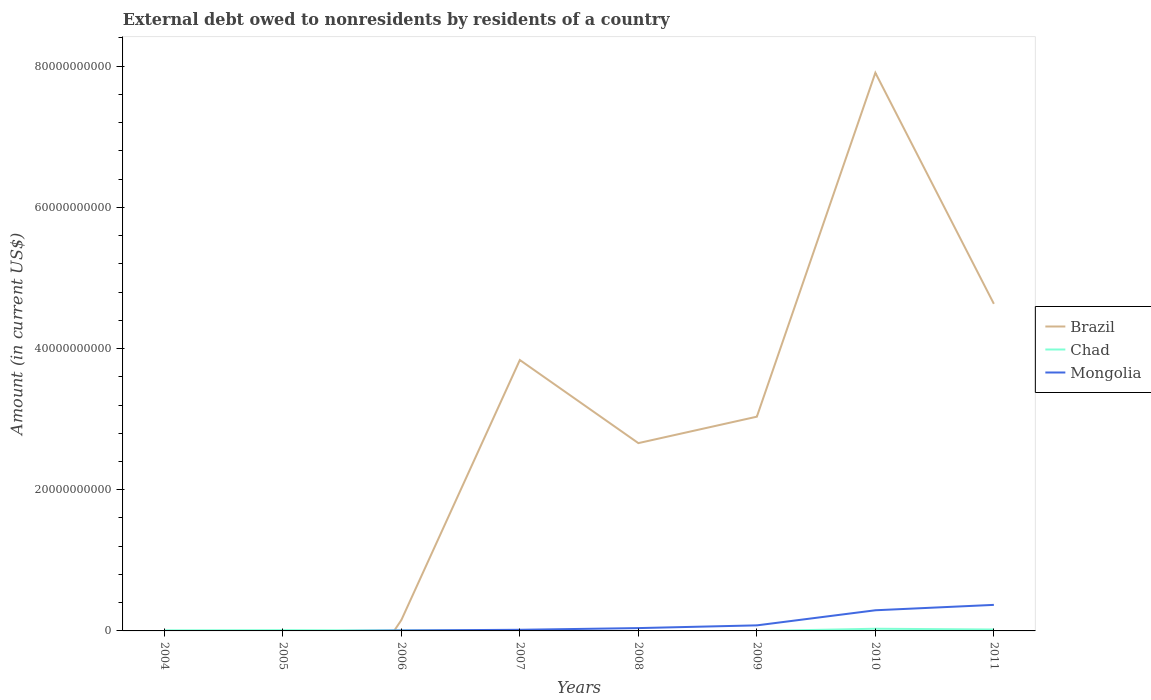How many different coloured lines are there?
Give a very brief answer. 3. Across all years, what is the maximum external debt owed by residents in Brazil?
Ensure brevity in your answer.  0. What is the total external debt owed by residents in Chad in the graph?
Offer a very short reply. -9.06e+07. What is the difference between the highest and the second highest external debt owed by residents in Mongolia?
Ensure brevity in your answer.  3.69e+09. What is the difference between the highest and the lowest external debt owed by residents in Chad?
Offer a terse response. 3. How many lines are there?
Provide a short and direct response. 3. Are the values on the major ticks of Y-axis written in scientific E-notation?
Ensure brevity in your answer.  No. Does the graph contain grids?
Keep it short and to the point. No. Where does the legend appear in the graph?
Ensure brevity in your answer.  Center right. How many legend labels are there?
Give a very brief answer. 3. What is the title of the graph?
Offer a very short reply. External debt owed to nonresidents by residents of a country. What is the Amount (in current US$) of Chad in 2004?
Keep it short and to the point. 8.47e+07. What is the Amount (in current US$) in Mongolia in 2004?
Offer a terse response. 0. What is the Amount (in current US$) in Brazil in 2005?
Your answer should be very brief. 0. What is the Amount (in current US$) of Chad in 2005?
Make the answer very short. 1.09e+08. What is the Amount (in current US$) in Brazil in 2006?
Keep it short and to the point. 1.54e+09. What is the Amount (in current US$) of Chad in 2006?
Offer a terse response. 6.11e+07. What is the Amount (in current US$) in Mongolia in 2006?
Give a very brief answer. 6.25e+07. What is the Amount (in current US$) in Brazil in 2007?
Keep it short and to the point. 3.84e+1. What is the Amount (in current US$) of Chad in 2007?
Provide a short and direct response. 2.07e+07. What is the Amount (in current US$) of Mongolia in 2007?
Give a very brief answer. 1.62e+08. What is the Amount (in current US$) in Brazil in 2008?
Offer a terse response. 2.66e+1. What is the Amount (in current US$) in Mongolia in 2008?
Keep it short and to the point. 4.01e+08. What is the Amount (in current US$) of Brazil in 2009?
Offer a very short reply. 3.03e+1. What is the Amount (in current US$) in Chad in 2009?
Ensure brevity in your answer.  0. What is the Amount (in current US$) in Mongolia in 2009?
Your answer should be very brief. 7.87e+08. What is the Amount (in current US$) in Brazil in 2010?
Provide a short and direct response. 7.91e+1. What is the Amount (in current US$) of Chad in 2010?
Offer a very short reply. 3.11e+08. What is the Amount (in current US$) of Mongolia in 2010?
Provide a short and direct response. 2.93e+09. What is the Amount (in current US$) of Brazil in 2011?
Ensure brevity in your answer.  4.63e+1. What is the Amount (in current US$) of Chad in 2011?
Keep it short and to the point. 2.00e+08. What is the Amount (in current US$) in Mongolia in 2011?
Give a very brief answer. 3.69e+09. Across all years, what is the maximum Amount (in current US$) in Brazil?
Make the answer very short. 7.91e+1. Across all years, what is the maximum Amount (in current US$) in Chad?
Offer a terse response. 3.11e+08. Across all years, what is the maximum Amount (in current US$) of Mongolia?
Provide a succinct answer. 3.69e+09. Across all years, what is the minimum Amount (in current US$) of Brazil?
Provide a succinct answer. 0. Across all years, what is the minimum Amount (in current US$) in Chad?
Offer a terse response. 0. What is the total Amount (in current US$) in Brazil in the graph?
Your answer should be compact. 2.22e+11. What is the total Amount (in current US$) of Chad in the graph?
Give a very brief answer. 7.86e+08. What is the total Amount (in current US$) of Mongolia in the graph?
Provide a succinct answer. 8.03e+09. What is the difference between the Amount (in current US$) of Chad in 2004 and that in 2005?
Keep it short and to the point. -2.45e+07. What is the difference between the Amount (in current US$) of Chad in 2004 and that in 2006?
Offer a terse response. 2.37e+07. What is the difference between the Amount (in current US$) in Chad in 2004 and that in 2007?
Offer a very short reply. 6.41e+07. What is the difference between the Amount (in current US$) in Chad in 2004 and that in 2010?
Your answer should be compact. -2.26e+08. What is the difference between the Amount (in current US$) in Chad in 2004 and that in 2011?
Offer a very short reply. -1.15e+08. What is the difference between the Amount (in current US$) of Chad in 2005 and that in 2006?
Your response must be concise. 4.81e+07. What is the difference between the Amount (in current US$) of Chad in 2005 and that in 2007?
Ensure brevity in your answer.  8.85e+07. What is the difference between the Amount (in current US$) in Chad in 2005 and that in 2010?
Keep it short and to the point. -2.01e+08. What is the difference between the Amount (in current US$) of Chad in 2005 and that in 2011?
Provide a short and direct response. -9.06e+07. What is the difference between the Amount (in current US$) of Brazil in 2006 and that in 2007?
Provide a succinct answer. -3.68e+1. What is the difference between the Amount (in current US$) in Chad in 2006 and that in 2007?
Offer a terse response. 4.04e+07. What is the difference between the Amount (in current US$) of Mongolia in 2006 and that in 2007?
Your answer should be very brief. -9.96e+07. What is the difference between the Amount (in current US$) of Brazil in 2006 and that in 2008?
Offer a very short reply. -2.51e+1. What is the difference between the Amount (in current US$) of Mongolia in 2006 and that in 2008?
Offer a terse response. -3.38e+08. What is the difference between the Amount (in current US$) in Brazil in 2006 and that in 2009?
Your answer should be very brief. -2.88e+1. What is the difference between the Amount (in current US$) of Mongolia in 2006 and that in 2009?
Your answer should be compact. -7.25e+08. What is the difference between the Amount (in current US$) of Brazil in 2006 and that in 2010?
Keep it short and to the point. -7.75e+1. What is the difference between the Amount (in current US$) in Chad in 2006 and that in 2010?
Make the answer very short. -2.49e+08. What is the difference between the Amount (in current US$) of Mongolia in 2006 and that in 2010?
Offer a very short reply. -2.86e+09. What is the difference between the Amount (in current US$) in Brazil in 2006 and that in 2011?
Provide a short and direct response. -4.48e+1. What is the difference between the Amount (in current US$) in Chad in 2006 and that in 2011?
Your answer should be compact. -1.39e+08. What is the difference between the Amount (in current US$) of Mongolia in 2006 and that in 2011?
Your answer should be very brief. -3.63e+09. What is the difference between the Amount (in current US$) in Brazil in 2007 and that in 2008?
Your response must be concise. 1.18e+1. What is the difference between the Amount (in current US$) in Mongolia in 2007 and that in 2008?
Offer a terse response. -2.39e+08. What is the difference between the Amount (in current US$) in Brazil in 2007 and that in 2009?
Offer a very short reply. 8.03e+09. What is the difference between the Amount (in current US$) in Mongolia in 2007 and that in 2009?
Give a very brief answer. -6.25e+08. What is the difference between the Amount (in current US$) of Brazil in 2007 and that in 2010?
Offer a terse response. -4.07e+1. What is the difference between the Amount (in current US$) in Chad in 2007 and that in 2010?
Keep it short and to the point. -2.90e+08. What is the difference between the Amount (in current US$) in Mongolia in 2007 and that in 2010?
Ensure brevity in your answer.  -2.76e+09. What is the difference between the Amount (in current US$) of Brazil in 2007 and that in 2011?
Provide a succinct answer. -7.96e+09. What is the difference between the Amount (in current US$) in Chad in 2007 and that in 2011?
Offer a very short reply. -1.79e+08. What is the difference between the Amount (in current US$) of Mongolia in 2007 and that in 2011?
Offer a very short reply. -3.53e+09. What is the difference between the Amount (in current US$) of Brazil in 2008 and that in 2009?
Your answer should be very brief. -3.74e+09. What is the difference between the Amount (in current US$) of Mongolia in 2008 and that in 2009?
Ensure brevity in your answer.  -3.87e+08. What is the difference between the Amount (in current US$) of Brazil in 2008 and that in 2010?
Provide a succinct answer. -5.25e+1. What is the difference between the Amount (in current US$) of Mongolia in 2008 and that in 2010?
Provide a short and direct response. -2.52e+09. What is the difference between the Amount (in current US$) in Brazil in 2008 and that in 2011?
Provide a succinct answer. -1.97e+1. What is the difference between the Amount (in current US$) in Mongolia in 2008 and that in 2011?
Make the answer very short. -3.29e+09. What is the difference between the Amount (in current US$) of Brazil in 2009 and that in 2010?
Keep it short and to the point. -4.87e+1. What is the difference between the Amount (in current US$) in Mongolia in 2009 and that in 2010?
Provide a succinct answer. -2.14e+09. What is the difference between the Amount (in current US$) in Brazil in 2009 and that in 2011?
Your answer should be compact. -1.60e+1. What is the difference between the Amount (in current US$) of Mongolia in 2009 and that in 2011?
Your answer should be compact. -2.90e+09. What is the difference between the Amount (in current US$) in Brazil in 2010 and that in 2011?
Your response must be concise. 3.27e+1. What is the difference between the Amount (in current US$) of Chad in 2010 and that in 2011?
Keep it short and to the point. 1.11e+08. What is the difference between the Amount (in current US$) of Mongolia in 2010 and that in 2011?
Provide a short and direct response. -7.64e+08. What is the difference between the Amount (in current US$) of Chad in 2004 and the Amount (in current US$) of Mongolia in 2006?
Offer a very short reply. 2.22e+07. What is the difference between the Amount (in current US$) of Chad in 2004 and the Amount (in current US$) of Mongolia in 2007?
Ensure brevity in your answer.  -7.74e+07. What is the difference between the Amount (in current US$) in Chad in 2004 and the Amount (in current US$) in Mongolia in 2008?
Offer a very short reply. -3.16e+08. What is the difference between the Amount (in current US$) of Chad in 2004 and the Amount (in current US$) of Mongolia in 2009?
Keep it short and to the point. -7.03e+08. What is the difference between the Amount (in current US$) of Chad in 2004 and the Amount (in current US$) of Mongolia in 2010?
Ensure brevity in your answer.  -2.84e+09. What is the difference between the Amount (in current US$) in Chad in 2004 and the Amount (in current US$) in Mongolia in 2011?
Your answer should be compact. -3.60e+09. What is the difference between the Amount (in current US$) of Chad in 2005 and the Amount (in current US$) of Mongolia in 2006?
Your response must be concise. 4.67e+07. What is the difference between the Amount (in current US$) in Chad in 2005 and the Amount (in current US$) in Mongolia in 2007?
Ensure brevity in your answer.  -5.29e+07. What is the difference between the Amount (in current US$) of Chad in 2005 and the Amount (in current US$) of Mongolia in 2008?
Offer a terse response. -2.92e+08. What is the difference between the Amount (in current US$) in Chad in 2005 and the Amount (in current US$) in Mongolia in 2009?
Make the answer very short. -6.78e+08. What is the difference between the Amount (in current US$) of Chad in 2005 and the Amount (in current US$) of Mongolia in 2010?
Give a very brief answer. -2.82e+09. What is the difference between the Amount (in current US$) in Chad in 2005 and the Amount (in current US$) in Mongolia in 2011?
Keep it short and to the point. -3.58e+09. What is the difference between the Amount (in current US$) in Brazil in 2006 and the Amount (in current US$) in Chad in 2007?
Provide a succinct answer. 1.52e+09. What is the difference between the Amount (in current US$) in Brazil in 2006 and the Amount (in current US$) in Mongolia in 2007?
Your answer should be compact. 1.38e+09. What is the difference between the Amount (in current US$) in Chad in 2006 and the Amount (in current US$) in Mongolia in 2007?
Offer a very short reply. -1.01e+08. What is the difference between the Amount (in current US$) in Brazil in 2006 and the Amount (in current US$) in Mongolia in 2008?
Keep it short and to the point. 1.14e+09. What is the difference between the Amount (in current US$) of Chad in 2006 and the Amount (in current US$) of Mongolia in 2008?
Keep it short and to the point. -3.40e+08. What is the difference between the Amount (in current US$) in Brazil in 2006 and the Amount (in current US$) in Mongolia in 2009?
Your answer should be very brief. 7.50e+08. What is the difference between the Amount (in current US$) in Chad in 2006 and the Amount (in current US$) in Mongolia in 2009?
Make the answer very short. -7.26e+08. What is the difference between the Amount (in current US$) of Brazil in 2006 and the Amount (in current US$) of Chad in 2010?
Your answer should be very brief. 1.23e+09. What is the difference between the Amount (in current US$) in Brazil in 2006 and the Amount (in current US$) in Mongolia in 2010?
Give a very brief answer. -1.39e+09. What is the difference between the Amount (in current US$) in Chad in 2006 and the Amount (in current US$) in Mongolia in 2010?
Provide a succinct answer. -2.86e+09. What is the difference between the Amount (in current US$) in Brazil in 2006 and the Amount (in current US$) in Chad in 2011?
Offer a terse response. 1.34e+09. What is the difference between the Amount (in current US$) in Brazil in 2006 and the Amount (in current US$) in Mongolia in 2011?
Offer a very short reply. -2.15e+09. What is the difference between the Amount (in current US$) of Chad in 2006 and the Amount (in current US$) of Mongolia in 2011?
Provide a succinct answer. -3.63e+09. What is the difference between the Amount (in current US$) in Brazil in 2007 and the Amount (in current US$) in Mongolia in 2008?
Make the answer very short. 3.80e+1. What is the difference between the Amount (in current US$) in Chad in 2007 and the Amount (in current US$) in Mongolia in 2008?
Give a very brief answer. -3.80e+08. What is the difference between the Amount (in current US$) of Brazil in 2007 and the Amount (in current US$) of Mongolia in 2009?
Ensure brevity in your answer.  3.76e+1. What is the difference between the Amount (in current US$) in Chad in 2007 and the Amount (in current US$) in Mongolia in 2009?
Make the answer very short. -7.67e+08. What is the difference between the Amount (in current US$) in Brazil in 2007 and the Amount (in current US$) in Chad in 2010?
Provide a short and direct response. 3.81e+1. What is the difference between the Amount (in current US$) of Brazil in 2007 and the Amount (in current US$) of Mongolia in 2010?
Provide a short and direct response. 3.54e+1. What is the difference between the Amount (in current US$) in Chad in 2007 and the Amount (in current US$) in Mongolia in 2010?
Give a very brief answer. -2.90e+09. What is the difference between the Amount (in current US$) of Brazil in 2007 and the Amount (in current US$) of Chad in 2011?
Keep it short and to the point. 3.82e+1. What is the difference between the Amount (in current US$) in Brazil in 2007 and the Amount (in current US$) in Mongolia in 2011?
Give a very brief answer. 3.47e+1. What is the difference between the Amount (in current US$) of Chad in 2007 and the Amount (in current US$) of Mongolia in 2011?
Provide a short and direct response. -3.67e+09. What is the difference between the Amount (in current US$) of Brazil in 2008 and the Amount (in current US$) of Mongolia in 2009?
Provide a succinct answer. 2.58e+1. What is the difference between the Amount (in current US$) of Brazil in 2008 and the Amount (in current US$) of Chad in 2010?
Offer a terse response. 2.63e+1. What is the difference between the Amount (in current US$) of Brazil in 2008 and the Amount (in current US$) of Mongolia in 2010?
Offer a very short reply. 2.37e+1. What is the difference between the Amount (in current US$) of Brazil in 2008 and the Amount (in current US$) of Chad in 2011?
Ensure brevity in your answer.  2.64e+1. What is the difference between the Amount (in current US$) in Brazil in 2008 and the Amount (in current US$) in Mongolia in 2011?
Provide a short and direct response. 2.29e+1. What is the difference between the Amount (in current US$) in Brazil in 2009 and the Amount (in current US$) in Chad in 2010?
Provide a succinct answer. 3.00e+1. What is the difference between the Amount (in current US$) in Brazil in 2009 and the Amount (in current US$) in Mongolia in 2010?
Offer a terse response. 2.74e+1. What is the difference between the Amount (in current US$) of Brazil in 2009 and the Amount (in current US$) of Chad in 2011?
Provide a short and direct response. 3.01e+1. What is the difference between the Amount (in current US$) in Brazil in 2009 and the Amount (in current US$) in Mongolia in 2011?
Provide a succinct answer. 2.67e+1. What is the difference between the Amount (in current US$) in Brazil in 2010 and the Amount (in current US$) in Chad in 2011?
Ensure brevity in your answer.  7.89e+1. What is the difference between the Amount (in current US$) in Brazil in 2010 and the Amount (in current US$) in Mongolia in 2011?
Make the answer very short. 7.54e+1. What is the difference between the Amount (in current US$) in Chad in 2010 and the Amount (in current US$) in Mongolia in 2011?
Your answer should be compact. -3.38e+09. What is the average Amount (in current US$) of Brazil per year?
Provide a succinct answer. 2.78e+1. What is the average Amount (in current US$) in Chad per year?
Make the answer very short. 9.83e+07. What is the average Amount (in current US$) in Mongolia per year?
Keep it short and to the point. 1.00e+09. In the year 2006, what is the difference between the Amount (in current US$) of Brazil and Amount (in current US$) of Chad?
Offer a terse response. 1.48e+09. In the year 2006, what is the difference between the Amount (in current US$) in Brazil and Amount (in current US$) in Mongolia?
Give a very brief answer. 1.47e+09. In the year 2006, what is the difference between the Amount (in current US$) in Chad and Amount (in current US$) in Mongolia?
Your answer should be compact. -1.45e+06. In the year 2007, what is the difference between the Amount (in current US$) in Brazil and Amount (in current US$) in Chad?
Make the answer very short. 3.84e+1. In the year 2007, what is the difference between the Amount (in current US$) in Brazil and Amount (in current US$) in Mongolia?
Offer a terse response. 3.82e+1. In the year 2007, what is the difference between the Amount (in current US$) in Chad and Amount (in current US$) in Mongolia?
Ensure brevity in your answer.  -1.41e+08. In the year 2008, what is the difference between the Amount (in current US$) in Brazil and Amount (in current US$) in Mongolia?
Your answer should be very brief. 2.62e+1. In the year 2009, what is the difference between the Amount (in current US$) in Brazil and Amount (in current US$) in Mongolia?
Make the answer very short. 2.96e+1. In the year 2010, what is the difference between the Amount (in current US$) of Brazil and Amount (in current US$) of Chad?
Give a very brief answer. 7.87e+1. In the year 2010, what is the difference between the Amount (in current US$) of Brazil and Amount (in current US$) of Mongolia?
Your answer should be compact. 7.61e+1. In the year 2010, what is the difference between the Amount (in current US$) of Chad and Amount (in current US$) of Mongolia?
Provide a short and direct response. -2.61e+09. In the year 2011, what is the difference between the Amount (in current US$) in Brazil and Amount (in current US$) in Chad?
Your response must be concise. 4.61e+1. In the year 2011, what is the difference between the Amount (in current US$) of Brazil and Amount (in current US$) of Mongolia?
Your response must be concise. 4.26e+1. In the year 2011, what is the difference between the Amount (in current US$) of Chad and Amount (in current US$) of Mongolia?
Your answer should be very brief. -3.49e+09. What is the ratio of the Amount (in current US$) in Chad in 2004 to that in 2005?
Your answer should be compact. 0.78. What is the ratio of the Amount (in current US$) in Chad in 2004 to that in 2006?
Offer a very short reply. 1.39. What is the ratio of the Amount (in current US$) of Chad in 2004 to that in 2007?
Your answer should be compact. 4.1. What is the ratio of the Amount (in current US$) of Chad in 2004 to that in 2010?
Your response must be concise. 0.27. What is the ratio of the Amount (in current US$) of Chad in 2004 to that in 2011?
Give a very brief answer. 0.42. What is the ratio of the Amount (in current US$) of Chad in 2005 to that in 2006?
Your answer should be very brief. 1.79. What is the ratio of the Amount (in current US$) of Chad in 2005 to that in 2007?
Provide a short and direct response. 5.28. What is the ratio of the Amount (in current US$) in Chad in 2005 to that in 2010?
Your response must be concise. 0.35. What is the ratio of the Amount (in current US$) in Chad in 2005 to that in 2011?
Your response must be concise. 0.55. What is the ratio of the Amount (in current US$) in Brazil in 2006 to that in 2007?
Provide a short and direct response. 0.04. What is the ratio of the Amount (in current US$) of Chad in 2006 to that in 2007?
Your answer should be compact. 2.95. What is the ratio of the Amount (in current US$) in Mongolia in 2006 to that in 2007?
Your answer should be compact. 0.39. What is the ratio of the Amount (in current US$) in Brazil in 2006 to that in 2008?
Offer a terse response. 0.06. What is the ratio of the Amount (in current US$) of Mongolia in 2006 to that in 2008?
Make the answer very short. 0.16. What is the ratio of the Amount (in current US$) of Brazil in 2006 to that in 2009?
Provide a succinct answer. 0.05. What is the ratio of the Amount (in current US$) in Mongolia in 2006 to that in 2009?
Your response must be concise. 0.08. What is the ratio of the Amount (in current US$) of Brazil in 2006 to that in 2010?
Keep it short and to the point. 0.02. What is the ratio of the Amount (in current US$) in Chad in 2006 to that in 2010?
Provide a succinct answer. 0.2. What is the ratio of the Amount (in current US$) in Mongolia in 2006 to that in 2010?
Your response must be concise. 0.02. What is the ratio of the Amount (in current US$) of Brazil in 2006 to that in 2011?
Your answer should be compact. 0.03. What is the ratio of the Amount (in current US$) in Chad in 2006 to that in 2011?
Offer a terse response. 0.31. What is the ratio of the Amount (in current US$) in Mongolia in 2006 to that in 2011?
Your answer should be compact. 0.02. What is the ratio of the Amount (in current US$) in Brazil in 2007 to that in 2008?
Your answer should be compact. 1.44. What is the ratio of the Amount (in current US$) of Mongolia in 2007 to that in 2008?
Your response must be concise. 0.4. What is the ratio of the Amount (in current US$) of Brazil in 2007 to that in 2009?
Provide a short and direct response. 1.26. What is the ratio of the Amount (in current US$) of Mongolia in 2007 to that in 2009?
Offer a terse response. 0.21. What is the ratio of the Amount (in current US$) of Brazil in 2007 to that in 2010?
Provide a short and direct response. 0.49. What is the ratio of the Amount (in current US$) of Chad in 2007 to that in 2010?
Make the answer very short. 0.07. What is the ratio of the Amount (in current US$) of Mongolia in 2007 to that in 2010?
Provide a succinct answer. 0.06. What is the ratio of the Amount (in current US$) of Brazil in 2007 to that in 2011?
Offer a terse response. 0.83. What is the ratio of the Amount (in current US$) in Chad in 2007 to that in 2011?
Provide a succinct answer. 0.1. What is the ratio of the Amount (in current US$) in Mongolia in 2007 to that in 2011?
Make the answer very short. 0.04. What is the ratio of the Amount (in current US$) of Brazil in 2008 to that in 2009?
Keep it short and to the point. 0.88. What is the ratio of the Amount (in current US$) of Mongolia in 2008 to that in 2009?
Provide a succinct answer. 0.51. What is the ratio of the Amount (in current US$) of Brazil in 2008 to that in 2010?
Your answer should be very brief. 0.34. What is the ratio of the Amount (in current US$) in Mongolia in 2008 to that in 2010?
Make the answer very short. 0.14. What is the ratio of the Amount (in current US$) in Brazil in 2008 to that in 2011?
Ensure brevity in your answer.  0.57. What is the ratio of the Amount (in current US$) in Mongolia in 2008 to that in 2011?
Give a very brief answer. 0.11. What is the ratio of the Amount (in current US$) in Brazil in 2009 to that in 2010?
Your answer should be compact. 0.38. What is the ratio of the Amount (in current US$) of Mongolia in 2009 to that in 2010?
Make the answer very short. 0.27. What is the ratio of the Amount (in current US$) in Brazil in 2009 to that in 2011?
Offer a terse response. 0.66. What is the ratio of the Amount (in current US$) of Mongolia in 2009 to that in 2011?
Offer a terse response. 0.21. What is the ratio of the Amount (in current US$) of Brazil in 2010 to that in 2011?
Provide a short and direct response. 1.71. What is the ratio of the Amount (in current US$) in Chad in 2010 to that in 2011?
Offer a very short reply. 1.55. What is the ratio of the Amount (in current US$) in Mongolia in 2010 to that in 2011?
Keep it short and to the point. 0.79. What is the difference between the highest and the second highest Amount (in current US$) of Brazil?
Ensure brevity in your answer.  3.27e+1. What is the difference between the highest and the second highest Amount (in current US$) in Chad?
Your response must be concise. 1.11e+08. What is the difference between the highest and the second highest Amount (in current US$) in Mongolia?
Ensure brevity in your answer.  7.64e+08. What is the difference between the highest and the lowest Amount (in current US$) of Brazil?
Your response must be concise. 7.91e+1. What is the difference between the highest and the lowest Amount (in current US$) of Chad?
Make the answer very short. 3.11e+08. What is the difference between the highest and the lowest Amount (in current US$) in Mongolia?
Provide a succinct answer. 3.69e+09. 